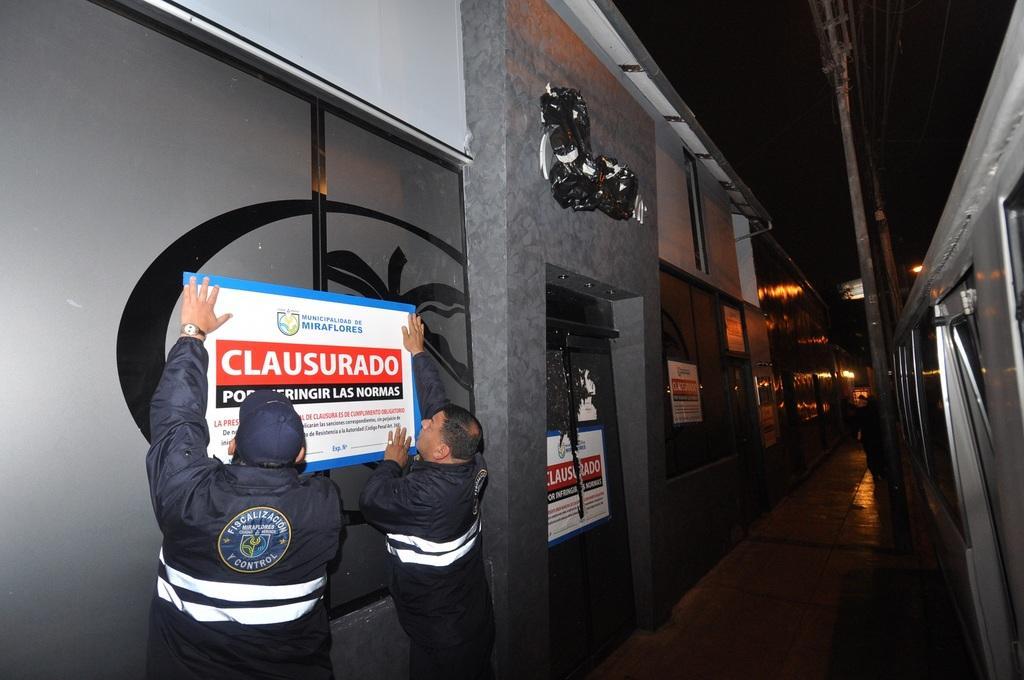How would you summarize this image in a sentence or two? In this picture I can see buildings and few posters with some text and I can see couple of men trying to stick a poster and I can see couple of poles. 